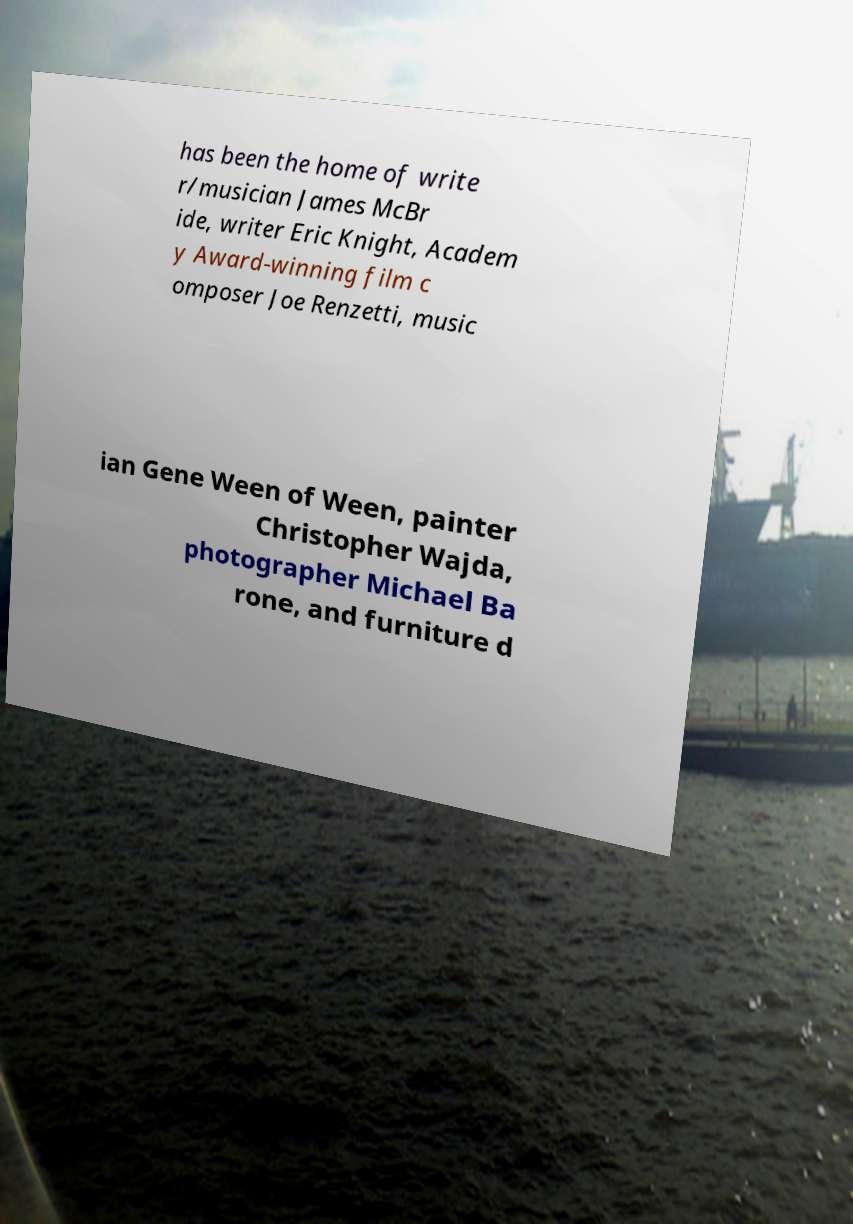Can you accurately transcribe the text from the provided image for me? has been the home of write r/musician James McBr ide, writer Eric Knight, Academ y Award-winning film c omposer Joe Renzetti, music ian Gene Ween of Ween, painter Christopher Wajda, photographer Michael Ba rone, and furniture d 